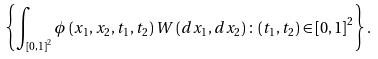<formula> <loc_0><loc_0><loc_500><loc_500>\left \{ \int _ { \left [ 0 , 1 \right ] ^ { 2 } } \phi \left ( x _ { 1 } , x _ { 2 } , t _ { 1 } , t _ { 2 } \right ) W \left ( d x _ { 1 } , d x _ { 2 } \right ) \colon \left ( t _ { 1 } , t _ { 2 } \right ) \in \left [ 0 , 1 \right ] ^ { 2 } \right \} .</formula> 